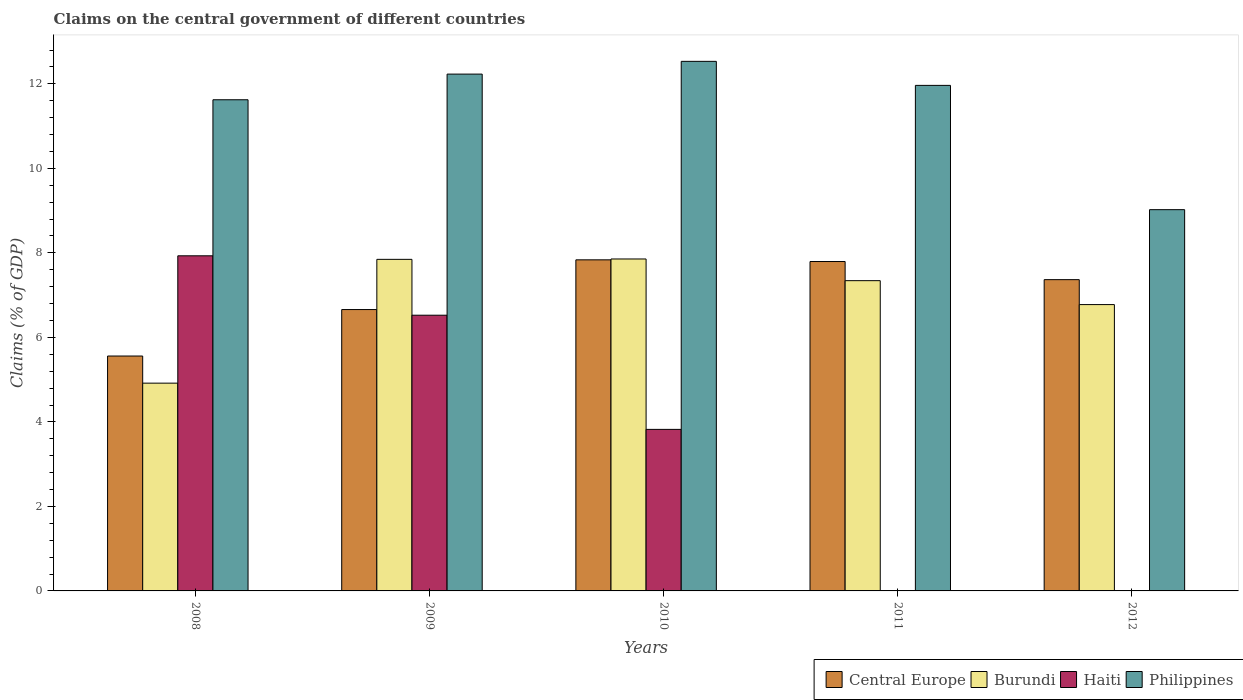How many groups of bars are there?
Make the answer very short. 5. How many bars are there on the 2nd tick from the right?
Offer a very short reply. 3. What is the percentage of GDP claimed on the central government in Haiti in 2009?
Ensure brevity in your answer.  6.53. Across all years, what is the maximum percentage of GDP claimed on the central government in Central Europe?
Give a very brief answer. 7.84. Across all years, what is the minimum percentage of GDP claimed on the central government in Burundi?
Give a very brief answer. 4.92. In which year was the percentage of GDP claimed on the central government in Burundi maximum?
Provide a succinct answer. 2010. What is the total percentage of GDP claimed on the central government in Central Europe in the graph?
Your response must be concise. 35.22. What is the difference between the percentage of GDP claimed on the central government in Philippines in 2010 and that in 2011?
Provide a succinct answer. 0.57. What is the difference between the percentage of GDP claimed on the central government in Burundi in 2008 and the percentage of GDP claimed on the central government in Philippines in 2009?
Offer a terse response. -7.31. What is the average percentage of GDP claimed on the central government in Central Europe per year?
Ensure brevity in your answer.  7.04. In the year 2010, what is the difference between the percentage of GDP claimed on the central government in Central Europe and percentage of GDP claimed on the central government in Philippines?
Ensure brevity in your answer.  -4.7. What is the ratio of the percentage of GDP claimed on the central government in Central Europe in 2008 to that in 2009?
Your answer should be very brief. 0.83. What is the difference between the highest and the second highest percentage of GDP claimed on the central government in Burundi?
Provide a short and direct response. 0.01. What is the difference between the highest and the lowest percentage of GDP claimed on the central government in Burundi?
Keep it short and to the point. 2.94. In how many years, is the percentage of GDP claimed on the central government in Central Europe greater than the average percentage of GDP claimed on the central government in Central Europe taken over all years?
Give a very brief answer. 3. Are all the bars in the graph horizontal?
Ensure brevity in your answer.  No. Does the graph contain any zero values?
Your answer should be compact. Yes. Where does the legend appear in the graph?
Ensure brevity in your answer.  Bottom right. How many legend labels are there?
Your answer should be very brief. 4. What is the title of the graph?
Ensure brevity in your answer.  Claims on the central government of different countries. Does "Bahamas" appear as one of the legend labels in the graph?
Your answer should be very brief. No. What is the label or title of the Y-axis?
Offer a terse response. Claims (% of GDP). What is the Claims (% of GDP) of Central Europe in 2008?
Make the answer very short. 5.56. What is the Claims (% of GDP) of Burundi in 2008?
Give a very brief answer. 4.92. What is the Claims (% of GDP) in Haiti in 2008?
Offer a terse response. 7.93. What is the Claims (% of GDP) in Philippines in 2008?
Provide a succinct answer. 11.62. What is the Claims (% of GDP) of Central Europe in 2009?
Your response must be concise. 6.66. What is the Claims (% of GDP) in Burundi in 2009?
Offer a terse response. 7.85. What is the Claims (% of GDP) in Haiti in 2009?
Offer a terse response. 6.53. What is the Claims (% of GDP) of Philippines in 2009?
Your response must be concise. 12.23. What is the Claims (% of GDP) in Central Europe in 2010?
Your answer should be compact. 7.84. What is the Claims (% of GDP) of Burundi in 2010?
Offer a terse response. 7.86. What is the Claims (% of GDP) in Haiti in 2010?
Offer a terse response. 3.82. What is the Claims (% of GDP) in Philippines in 2010?
Provide a short and direct response. 12.53. What is the Claims (% of GDP) of Central Europe in 2011?
Provide a short and direct response. 7.8. What is the Claims (% of GDP) in Burundi in 2011?
Make the answer very short. 7.34. What is the Claims (% of GDP) of Haiti in 2011?
Provide a short and direct response. 0. What is the Claims (% of GDP) of Philippines in 2011?
Give a very brief answer. 11.96. What is the Claims (% of GDP) in Central Europe in 2012?
Provide a short and direct response. 7.37. What is the Claims (% of GDP) in Burundi in 2012?
Your answer should be compact. 6.78. What is the Claims (% of GDP) of Haiti in 2012?
Your response must be concise. 0. What is the Claims (% of GDP) in Philippines in 2012?
Provide a succinct answer. 9.02. Across all years, what is the maximum Claims (% of GDP) of Central Europe?
Your answer should be very brief. 7.84. Across all years, what is the maximum Claims (% of GDP) in Burundi?
Provide a succinct answer. 7.86. Across all years, what is the maximum Claims (% of GDP) in Haiti?
Ensure brevity in your answer.  7.93. Across all years, what is the maximum Claims (% of GDP) of Philippines?
Your answer should be compact. 12.53. Across all years, what is the minimum Claims (% of GDP) in Central Europe?
Provide a short and direct response. 5.56. Across all years, what is the minimum Claims (% of GDP) of Burundi?
Ensure brevity in your answer.  4.92. Across all years, what is the minimum Claims (% of GDP) in Haiti?
Provide a succinct answer. 0. Across all years, what is the minimum Claims (% of GDP) in Philippines?
Offer a terse response. 9.02. What is the total Claims (% of GDP) in Central Europe in the graph?
Make the answer very short. 35.22. What is the total Claims (% of GDP) in Burundi in the graph?
Keep it short and to the point. 34.74. What is the total Claims (% of GDP) of Haiti in the graph?
Keep it short and to the point. 18.28. What is the total Claims (% of GDP) of Philippines in the graph?
Provide a short and direct response. 57.38. What is the difference between the Claims (% of GDP) of Central Europe in 2008 and that in 2009?
Provide a short and direct response. -1.1. What is the difference between the Claims (% of GDP) in Burundi in 2008 and that in 2009?
Give a very brief answer. -2.93. What is the difference between the Claims (% of GDP) of Haiti in 2008 and that in 2009?
Your response must be concise. 1.41. What is the difference between the Claims (% of GDP) of Philippines in 2008 and that in 2009?
Offer a very short reply. -0.61. What is the difference between the Claims (% of GDP) in Central Europe in 2008 and that in 2010?
Provide a short and direct response. -2.28. What is the difference between the Claims (% of GDP) of Burundi in 2008 and that in 2010?
Provide a short and direct response. -2.94. What is the difference between the Claims (% of GDP) in Haiti in 2008 and that in 2010?
Provide a succinct answer. 4.11. What is the difference between the Claims (% of GDP) of Philippines in 2008 and that in 2010?
Your answer should be very brief. -0.91. What is the difference between the Claims (% of GDP) in Central Europe in 2008 and that in 2011?
Keep it short and to the point. -2.24. What is the difference between the Claims (% of GDP) in Burundi in 2008 and that in 2011?
Your response must be concise. -2.43. What is the difference between the Claims (% of GDP) in Philippines in 2008 and that in 2011?
Offer a very short reply. -0.34. What is the difference between the Claims (% of GDP) in Central Europe in 2008 and that in 2012?
Provide a succinct answer. -1.81. What is the difference between the Claims (% of GDP) of Burundi in 2008 and that in 2012?
Give a very brief answer. -1.86. What is the difference between the Claims (% of GDP) in Philippines in 2008 and that in 2012?
Your answer should be very brief. 2.6. What is the difference between the Claims (% of GDP) of Central Europe in 2009 and that in 2010?
Your answer should be very brief. -1.18. What is the difference between the Claims (% of GDP) in Burundi in 2009 and that in 2010?
Give a very brief answer. -0.01. What is the difference between the Claims (% of GDP) of Haiti in 2009 and that in 2010?
Provide a short and direct response. 2.7. What is the difference between the Claims (% of GDP) of Philippines in 2009 and that in 2010?
Offer a terse response. -0.3. What is the difference between the Claims (% of GDP) in Central Europe in 2009 and that in 2011?
Make the answer very short. -1.14. What is the difference between the Claims (% of GDP) in Burundi in 2009 and that in 2011?
Your answer should be compact. 0.5. What is the difference between the Claims (% of GDP) of Philippines in 2009 and that in 2011?
Provide a short and direct response. 0.27. What is the difference between the Claims (% of GDP) in Central Europe in 2009 and that in 2012?
Offer a very short reply. -0.71. What is the difference between the Claims (% of GDP) in Burundi in 2009 and that in 2012?
Provide a succinct answer. 1.07. What is the difference between the Claims (% of GDP) of Philippines in 2009 and that in 2012?
Your response must be concise. 3.21. What is the difference between the Claims (% of GDP) of Central Europe in 2010 and that in 2011?
Your response must be concise. 0.04. What is the difference between the Claims (% of GDP) in Burundi in 2010 and that in 2011?
Offer a terse response. 0.51. What is the difference between the Claims (% of GDP) in Philippines in 2010 and that in 2011?
Give a very brief answer. 0.57. What is the difference between the Claims (% of GDP) of Central Europe in 2010 and that in 2012?
Give a very brief answer. 0.47. What is the difference between the Claims (% of GDP) in Burundi in 2010 and that in 2012?
Your answer should be very brief. 1.08. What is the difference between the Claims (% of GDP) of Philippines in 2010 and that in 2012?
Keep it short and to the point. 3.51. What is the difference between the Claims (% of GDP) in Central Europe in 2011 and that in 2012?
Give a very brief answer. 0.43. What is the difference between the Claims (% of GDP) of Burundi in 2011 and that in 2012?
Offer a very short reply. 0.57. What is the difference between the Claims (% of GDP) in Philippines in 2011 and that in 2012?
Your answer should be compact. 2.94. What is the difference between the Claims (% of GDP) in Central Europe in 2008 and the Claims (% of GDP) in Burundi in 2009?
Offer a very short reply. -2.29. What is the difference between the Claims (% of GDP) in Central Europe in 2008 and the Claims (% of GDP) in Haiti in 2009?
Give a very brief answer. -0.97. What is the difference between the Claims (% of GDP) of Central Europe in 2008 and the Claims (% of GDP) of Philippines in 2009?
Your response must be concise. -6.67. What is the difference between the Claims (% of GDP) of Burundi in 2008 and the Claims (% of GDP) of Haiti in 2009?
Your answer should be compact. -1.61. What is the difference between the Claims (% of GDP) in Burundi in 2008 and the Claims (% of GDP) in Philippines in 2009?
Provide a short and direct response. -7.31. What is the difference between the Claims (% of GDP) of Haiti in 2008 and the Claims (% of GDP) of Philippines in 2009?
Offer a very short reply. -4.3. What is the difference between the Claims (% of GDP) in Central Europe in 2008 and the Claims (% of GDP) in Burundi in 2010?
Provide a short and direct response. -2.3. What is the difference between the Claims (% of GDP) in Central Europe in 2008 and the Claims (% of GDP) in Haiti in 2010?
Your answer should be compact. 1.74. What is the difference between the Claims (% of GDP) of Central Europe in 2008 and the Claims (% of GDP) of Philippines in 2010?
Give a very brief answer. -6.97. What is the difference between the Claims (% of GDP) in Burundi in 2008 and the Claims (% of GDP) in Haiti in 2010?
Provide a short and direct response. 1.09. What is the difference between the Claims (% of GDP) of Burundi in 2008 and the Claims (% of GDP) of Philippines in 2010?
Provide a succinct answer. -7.62. What is the difference between the Claims (% of GDP) in Haiti in 2008 and the Claims (% of GDP) in Philippines in 2010?
Your answer should be compact. -4.6. What is the difference between the Claims (% of GDP) of Central Europe in 2008 and the Claims (% of GDP) of Burundi in 2011?
Provide a succinct answer. -1.78. What is the difference between the Claims (% of GDP) of Central Europe in 2008 and the Claims (% of GDP) of Philippines in 2011?
Give a very brief answer. -6.41. What is the difference between the Claims (% of GDP) in Burundi in 2008 and the Claims (% of GDP) in Philippines in 2011?
Your response must be concise. -7.05. What is the difference between the Claims (% of GDP) in Haiti in 2008 and the Claims (% of GDP) in Philippines in 2011?
Your response must be concise. -4.03. What is the difference between the Claims (% of GDP) in Central Europe in 2008 and the Claims (% of GDP) in Burundi in 2012?
Your answer should be very brief. -1.22. What is the difference between the Claims (% of GDP) in Central Europe in 2008 and the Claims (% of GDP) in Philippines in 2012?
Make the answer very short. -3.46. What is the difference between the Claims (% of GDP) of Burundi in 2008 and the Claims (% of GDP) of Philippines in 2012?
Your response must be concise. -4.11. What is the difference between the Claims (% of GDP) of Haiti in 2008 and the Claims (% of GDP) of Philippines in 2012?
Your response must be concise. -1.09. What is the difference between the Claims (% of GDP) of Central Europe in 2009 and the Claims (% of GDP) of Burundi in 2010?
Give a very brief answer. -1.2. What is the difference between the Claims (% of GDP) of Central Europe in 2009 and the Claims (% of GDP) of Haiti in 2010?
Offer a terse response. 2.84. What is the difference between the Claims (% of GDP) in Central Europe in 2009 and the Claims (% of GDP) in Philippines in 2010?
Your response must be concise. -5.87. What is the difference between the Claims (% of GDP) in Burundi in 2009 and the Claims (% of GDP) in Haiti in 2010?
Your answer should be very brief. 4.02. What is the difference between the Claims (% of GDP) of Burundi in 2009 and the Claims (% of GDP) of Philippines in 2010?
Ensure brevity in your answer.  -4.69. What is the difference between the Claims (% of GDP) in Haiti in 2009 and the Claims (% of GDP) in Philippines in 2010?
Give a very brief answer. -6.01. What is the difference between the Claims (% of GDP) in Central Europe in 2009 and the Claims (% of GDP) in Burundi in 2011?
Give a very brief answer. -0.68. What is the difference between the Claims (% of GDP) in Central Europe in 2009 and the Claims (% of GDP) in Philippines in 2011?
Offer a terse response. -5.31. What is the difference between the Claims (% of GDP) of Burundi in 2009 and the Claims (% of GDP) of Philippines in 2011?
Give a very brief answer. -4.12. What is the difference between the Claims (% of GDP) in Haiti in 2009 and the Claims (% of GDP) in Philippines in 2011?
Ensure brevity in your answer.  -5.44. What is the difference between the Claims (% of GDP) in Central Europe in 2009 and the Claims (% of GDP) in Burundi in 2012?
Provide a short and direct response. -0.12. What is the difference between the Claims (% of GDP) of Central Europe in 2009 and the Claims (% of GDP) of Philippines in 2012?
Your answer should be compact. -2.36. What is the difference between the Claims (% of GDP) in Burundi in 2009 and the Claims (% of GDP) in Philippines in 2012?
Provide a short and direct response. -1.18. What is the difference between the Claims (% of GDP) of Haiti in 2009 and the Claims (% of GDP) of Philippines in 2012?
Provide a short and direct response. -2.5. What is the difference between the Claims (% of GDP) of Central Europe in 2010 and the Claims (% of GDP) of Burundi in 2011?
Offer a terse response. 0.49. What is the difference between the Claims (% of GDP) of Central Europe in 2010 and the Claims (% of GDP) of Philippines in 2011?
Your response must be concise. -4.13. What is the difference between the Claims (% of GDP) in Burundi in 2010 and the Claims (% of GDP) in Philippines in 2011?
Provide a succinct answer. -4.11. What is the difference between the Claims (% of GDP) in Haiti in 2010 and the Claims (% of GDP) in Philippines in 2011?
Make the answer very short. -8.14. What is the difference between the Claims (% of GDP) of Central Europe in 2010 and the Claims (% of GDP) of Burundi in 2012?
Provide a short and direct response. 1.06. What is the difference between the Claims (% of GDP) of Central Europe in 2010 and the Claims (% of GDP) of Philippines in 2012?
Your answer should be very brief. -1.19. What is the difference between the Claims (% of GDP) in Burundi in 2010 and the Claims (% of GDP) in Philippines in 2012?
Your answer should be very brief. -1.17. What is the difference between the Claims (% of GDP) of Haiti in 2010 and the Claims (% of GDP) of Philippines in 2012?
Provide a succinct answer. -5.2. What is the difference between the Claims (% of GDP) of Central Europe in 2011 and the Claims (% of GDP) of Burundi in 2012?
Provide a succinct answer. 1.02. What is the difference between the Claims (% of GDP) in Central Europe in 2011 and the Claims (% of GDP) in Philippines in 2012?
Offer a very short reply. -1.23. What is the difference between the Claims (% of GDP) of Burundi in 2011 and the Claims (% of GDP) of Philippines in 2012?
Your response must be concise. -1.68. What is the average Claims (% of GDP) in Central Europe per year?
Your answer should be very brief. 7.04. What is the average Claims (% of GDP) in Burundi per year?
Offer a very short reply. 6.95. What is the average Claims (% of GDP) of Haiti per year?
Your answer should be compact. 3.66. What is the average Claims (% of GDP) of Philippines per year?
Ensure brevity in your answer.  11.48. In the year 2008, what is the difference between the Claims (% of GDP) of Central Europe and Claims (% of GDP) of Burundi?
Keep it short and to the point. 0.64. In the year 2008, what is the difference between the Claims (% of GDP) of Central Europe and Claims (% of GDP) of Haiti?
Your answer should be compact. -2.37. In the year 2008, what is the difference between the Claims (% of GDP) in Central Europe and Claims (% of GDP) in Philippines?
Provide a short and direct response. -6.06. In the year 2008, what is the difference between the Claims (% of GDP) in Burundi and Claims (% of GDP) in Haiti?
Make the answer very short. -3.01. In the year 2008, what is the difference between the Claims (% of GDP) of Burundi and Claims (% of GDP) of Philippines?
Ensure brevity in your answer.  -6.71. In the year 2008, what is the difference between the Claims (% of GDP) of Haiti and Claims (% of GDP) of Philippines?
Ensure brevity in your answer.  -3.69. In the year 2009, what is the difference between the Claims (% of GDP) of Central Europe and Claims (% of GDP) of Burundi?
Your response must be concise. -1.19. In the year 2009, what is the difference between the Claims (% of GDP) of Central Europe and Claims (% of GDP) of Haiti?
Give a very brief answer. 0.13. In the year 2009, what is the difference between the Claims (% of GDP) in Central Europe and Claims (% of GDP) in Philippines?
Your response must be concise. -5.57. In the year 2009, what is the difference between the Claims (% of GDP) of Burundi and Claims (% of GDP) of Haiti?
Provide a short and direct response. 1.32. In the year 2009, what is the difference between the Claims (% of GDP) of Burundi and Claims (% of GDP) of Philippines?
Your answer should be compact. -4.38. In the year 2009, what is the difference between the Claims (% of GDP) of Haiti and Claims (% of GDP) of Philippines?
Offer a terse response. -5.71. In the year 2010, what is the difference between the Claims (% of GDP) in Central Europe and Claims (% of GDP) in Burundi?
Ensure brevity in your answer.  -0.02. In the year 2010, what is the difference between the Claims (% of GDP) of Central Europe and Claims (% of GDP) of Haiti?
Offer a terse response. 4.01. In the year 2010, what is the difference between the Claims (% of GDP) of Central Europe and Claims (% of GDP) of Philippines?
Your answer should be very brief. -4.7. In the year 2010, what is the difference between the Claims (% of GDP) in Burundi and Claims (% of GDP) in Haiti?
Ensure brevity in your answer.  4.03. In the year 2010, what is the difference between the Claims (% of GDP) of Burundi and Claims (% of GDP) of Philippines?
Your response must be concise. -4.68. In the year 2010, what is the difference between the Claims (% of GDP) of Haiti and Claims (% of GDP) of Philippines?
Your answer should be very brief. -8.71. In the year 2011, what is the difference between the Claims (% of GDP) of Central Europe and Claims (% of GDP) of Burundi?
Offer a terse response. 0.45. In the year 2011, what is the difference between the Claims (% of GDP) in Central Europe and Claims (% of GDP) in Philippines?
Your answer should be compact. -4.17. In the year 2011, what is the difference between the Claims (% of GDP) in Burundi and Claims (% of GDP) in Philippines?
Keep it short and to the point. -4.62. In the year 2012, what is the difference between the Claims (% of GDP) in Central Europe and Claims (% of GDP) in Burundi?
Your answer should be compact. 0.59. In the year 2012, what is the difference between the Claims (% of GDP) of Central Europe and Claims (% of GDP) of Philippines?
Provide a short and direct response. -1.66. In the year 2012, what is the difference between the Claims (% of GDP) in Burundi and Claims (% of GDP) in Philippines?
Keep it short and to the point. -2.25. What is the ratio of the Claims (% of GDP) of Central Europe in 2008 to that in 2009?
Ensure brevity in your answer.  0.83. What is the ratio of the Claims (% of GDP) of Burundi in 2008 to that in 2009?
Make the answer very short. 0.63. What is the ratio of the Claims (% of GDP) of Haiti in 2008 to that in 2009?
Your answer should be compact. 1.22. What is the ratio of the Claims (% of GDP) in Philippines in 2008 to that in 2009?
Give a very brief answer. 0.95. What is the ratio of the Claims (% of GDP) in Central Europe in 2008 to that in 2010?
Offer a very short reply. 0.71. What is the ratio of the Claims (% of GDP) of Burundi in 2008 to that in 2010?
Your answer should be very brief. 0.63. What is the ratio of the Claims (% of GDP) in Haiti in 2008 to that in 2010?
Give a very brief answer. 2.07. What is the ratio of the Claims (% of GDP) in Philippines in 2008 to that in 2010?
Your response must be concise. 0.93. What is the ratio of the Claims (% of GDP) of Central Europe in 2008 to that in 2011?
Provide a short and direct response. 0.71. What is the ratio of the Claims (% of GDP) of Burundi in 2008 to that in 2011?
Keep it short and to the point. 0.67. What is the ratio of the Claims (% of GDP) of Philippines in 2008 to that in 2011?
Provide a short and direct response. 0.97. What is the ratio of the Claims (% of GDP) of Central Europe in 2008 to that in 2012?
Offer a terse response. 0.75. What is the ratio of the Claims (% of GDP) of Burundi in 2008 to that in 2012?
Give a very brief answer. 0.73. What is the ratio of the Claims (% of GDP) of Philippines in 2008 to that in 2012?
Keep it short and to the point. 1.29. What is the ratio of the Claims (% of GDP) in Central Europe in 2009 to that in 2010?
Make the answer very short. 0.85. What is the ratio of the Claims (% of GDP) in Haiti in 2009 to that in 2010?
Keep it short and to the point. 1.71. What is the ratio of the Claims (% of GDP) in Philippines in 2009 to that in 2010?
Your response must be concise. 0.98. What is the ratio of the Claims (% of GDP) of Central Europe in 2009 to that in 2011?
Offer a very short reply. 0.85. What is the ratio of the Claims (% of GDP) of Burundi in 2009 to that in 2011?
Provide a succinct answer. 1.07. What is the ratio of the Claims (% of GDP) of Philippines in 2009 to that in 2011?
Provide a succinct answer. 1.02. What is the ratio of the Claims (% of GDP) of Central Europe in 2009 to that in 2012?
Your response must be concise. 0.9. What is the ratio of the Claims (% of GDP) in Burundi in 2009 to that in 2012?
Ensure brevity in your answer.  1.16. What is the ratio of the Claims (% of GDP) in Philippines in 2009 to that in 2012?
Make the answer very short. 1.36. What is the ratio of the Claims (% of GDP) in Burundi in 2010 to that in 2011?
Your answer should be very brief. 1.07. What is the ratio of the Claims (% of GDP) of Philippines in 2010 to that in 2011?
Provide a short and direct response. 1.05. What is the ratio of the Claims (% of GDP) of Central Europe in 2010 to that in 2012?
Ensure brevity in your answer.  1.06. What is the ratio of the Claims (% of GDP) in Burundi in 2010 to that in 2012?
Provide a short and direct response. 1.16. What is the ratio of the Claims (% of GDP) in Philippines in 2010 to that in 2012?
Ensure brevity in your answer.  1.39. What is the ratio of the Claims (% of GDP) of Central Europe in 2011 to that in 2012?
Provide a succinct answer. 1.06. What is the ratio of the Claims (% of GDP) of Burundi in 2011 to that in 2012?
Ensure brevity in your answer.  1.08. What is the ratio of the Claims (% of GDP) in Philippines in 2011 to that in 2012?
Ensure brevity in your answer.  1.33. What is the difference between the highest and the second highest Claims (% of GDP) of Central Europe?
Your response must be concise. 0.04. What is the difference between the highest and the second highest Claims (% of GDP) in Burundi?
Provide a succinct answer. 0.01. What is the difference between the highest and the second highest Claims (% of GDP) in Haiti?
Make the answer very short. 1.41. What is the difference between the highest and the second highest Claims (% of GDP) in Philippines?
Offer a terse response. 0.3. What is the difference between the highest and the lowest Claims (% of GDP) of Central Europe?
Keep it short and to the point. 2.28. What is the difference between the highest and the lowest Claims (% of GDP) in Burundi?
Ensure brevity in your answer.  2.94. What is the difference between the highest and the lowest Claims (% of GDP) of Haiti?
Give a very brief answer. 7.93. What is the difference between the highest and the lowest Claims (% of GDP) of Philippines?
Your answer should be very brief. 3.51. 